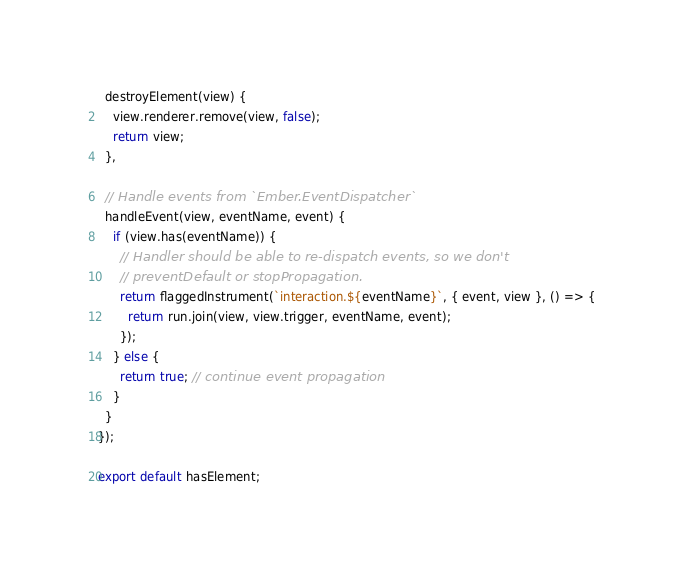<code> <loc_0><loc_0><loc_500><loc_500><_JavaScript_>
  destroyElement(view) {
    view.renderer.remove(view, false);
    return view;
  },

  // Handle events from `Ember.EventDispatcher`
  handleEvent(view, eventName, event) {
    if (view.has(eventName)) {
      // Handler should be able to re-dispatch events, so we don't
      // preventDefault or stopPropagation.
      return flaggedInstrument(`interaction.${eventName}`, { event, view }, () => {
        return run.join(view, view.trigger, eventName, event);
      });
    } else {
      return true; // continue event propagation
    }
  }
});

export default hasElement;
</code> 